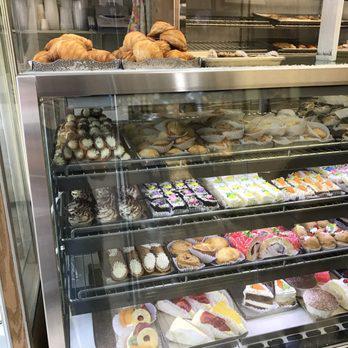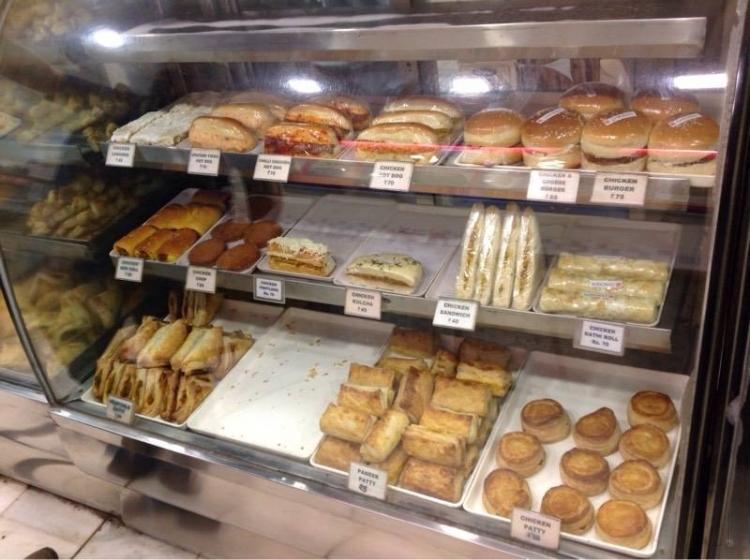The first image is the image on the left, the second image is the image on the right. Assess this claim about the two images: "In one image, a person is behind a curved, glass-fronted display with white packages on its top.". Correct or not? Answer yes or no. No. 